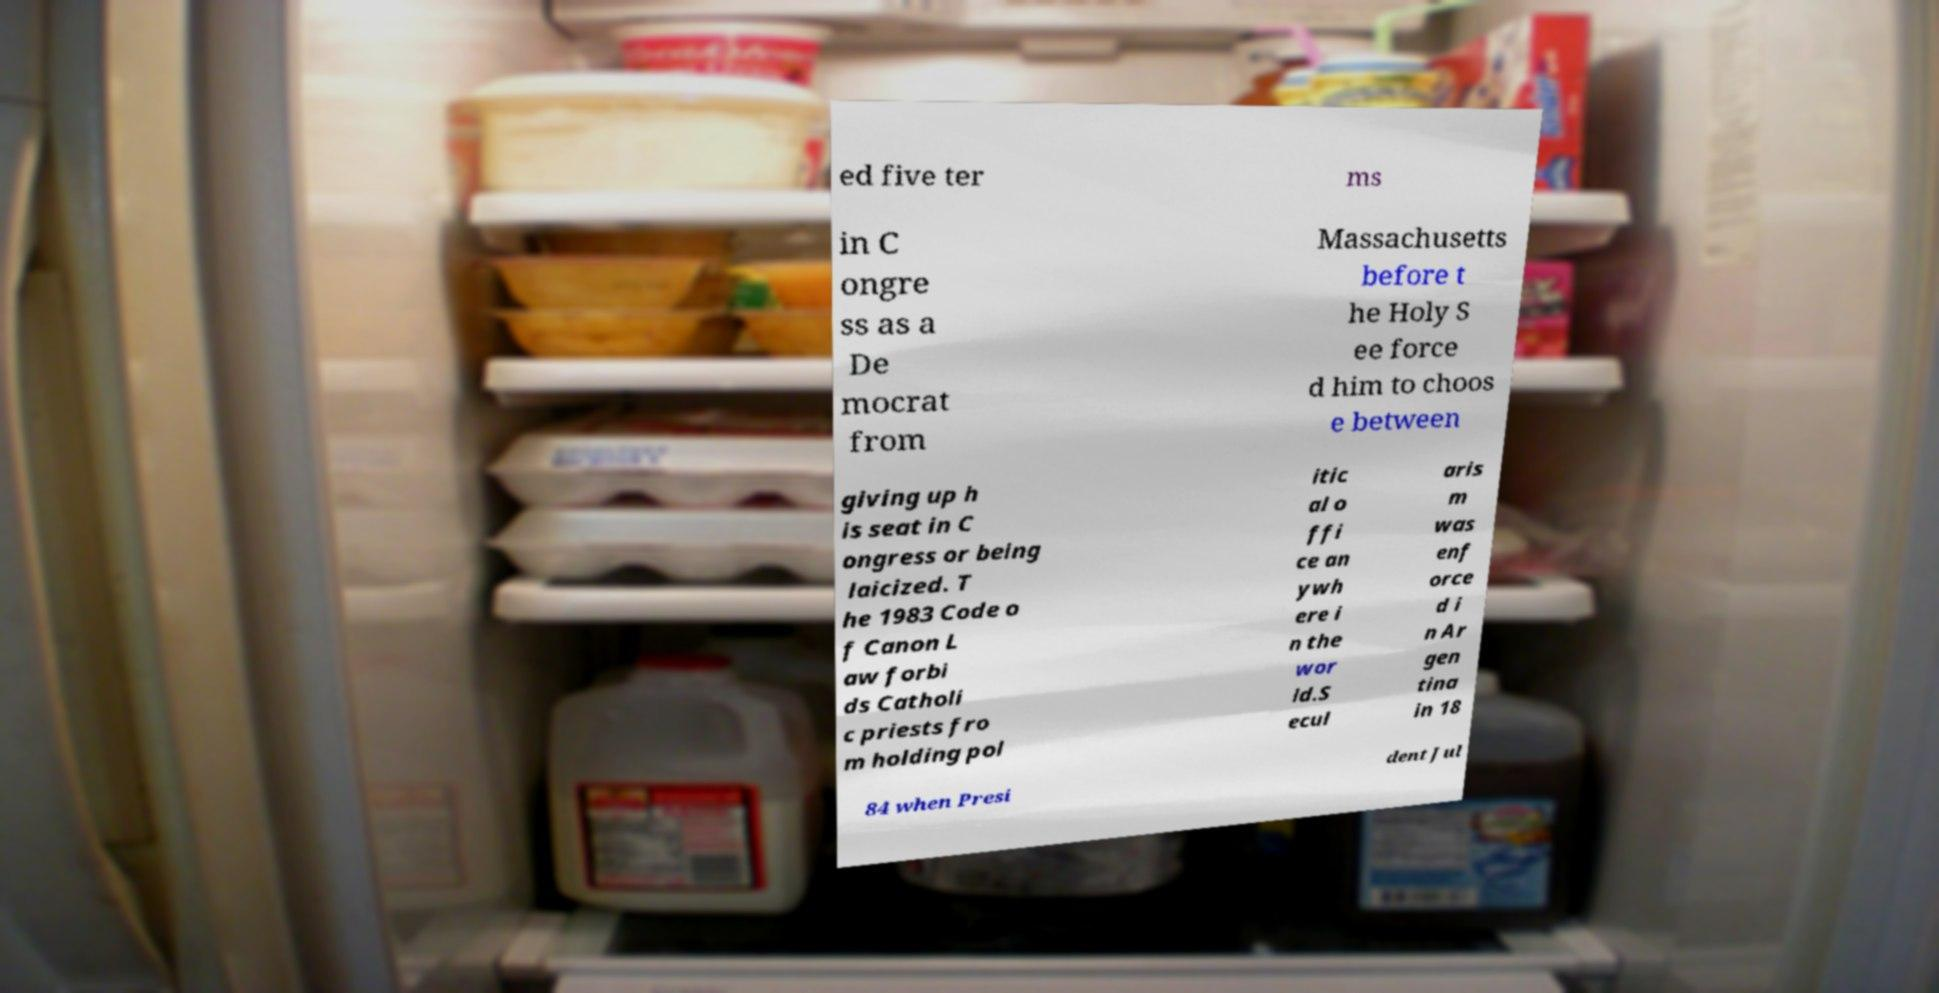There's text embedded in this image that I need extracted. Can you transcribe it verbatim? ed five ter ms in C ongre ss as a De mocrat from Massachusetts before t he Holy S ee force d him to choos e between giving up h is seat in C ongress or being laicized. T he 1983 Code o f Canon L aw forbi ds Catholi c priests fro m holding pol itic al o ffi ce an ywh ere i n the wor ld.S ecul aris m was enf orce d i n Ar gen tina in 18 84 when Presi dent Jul 